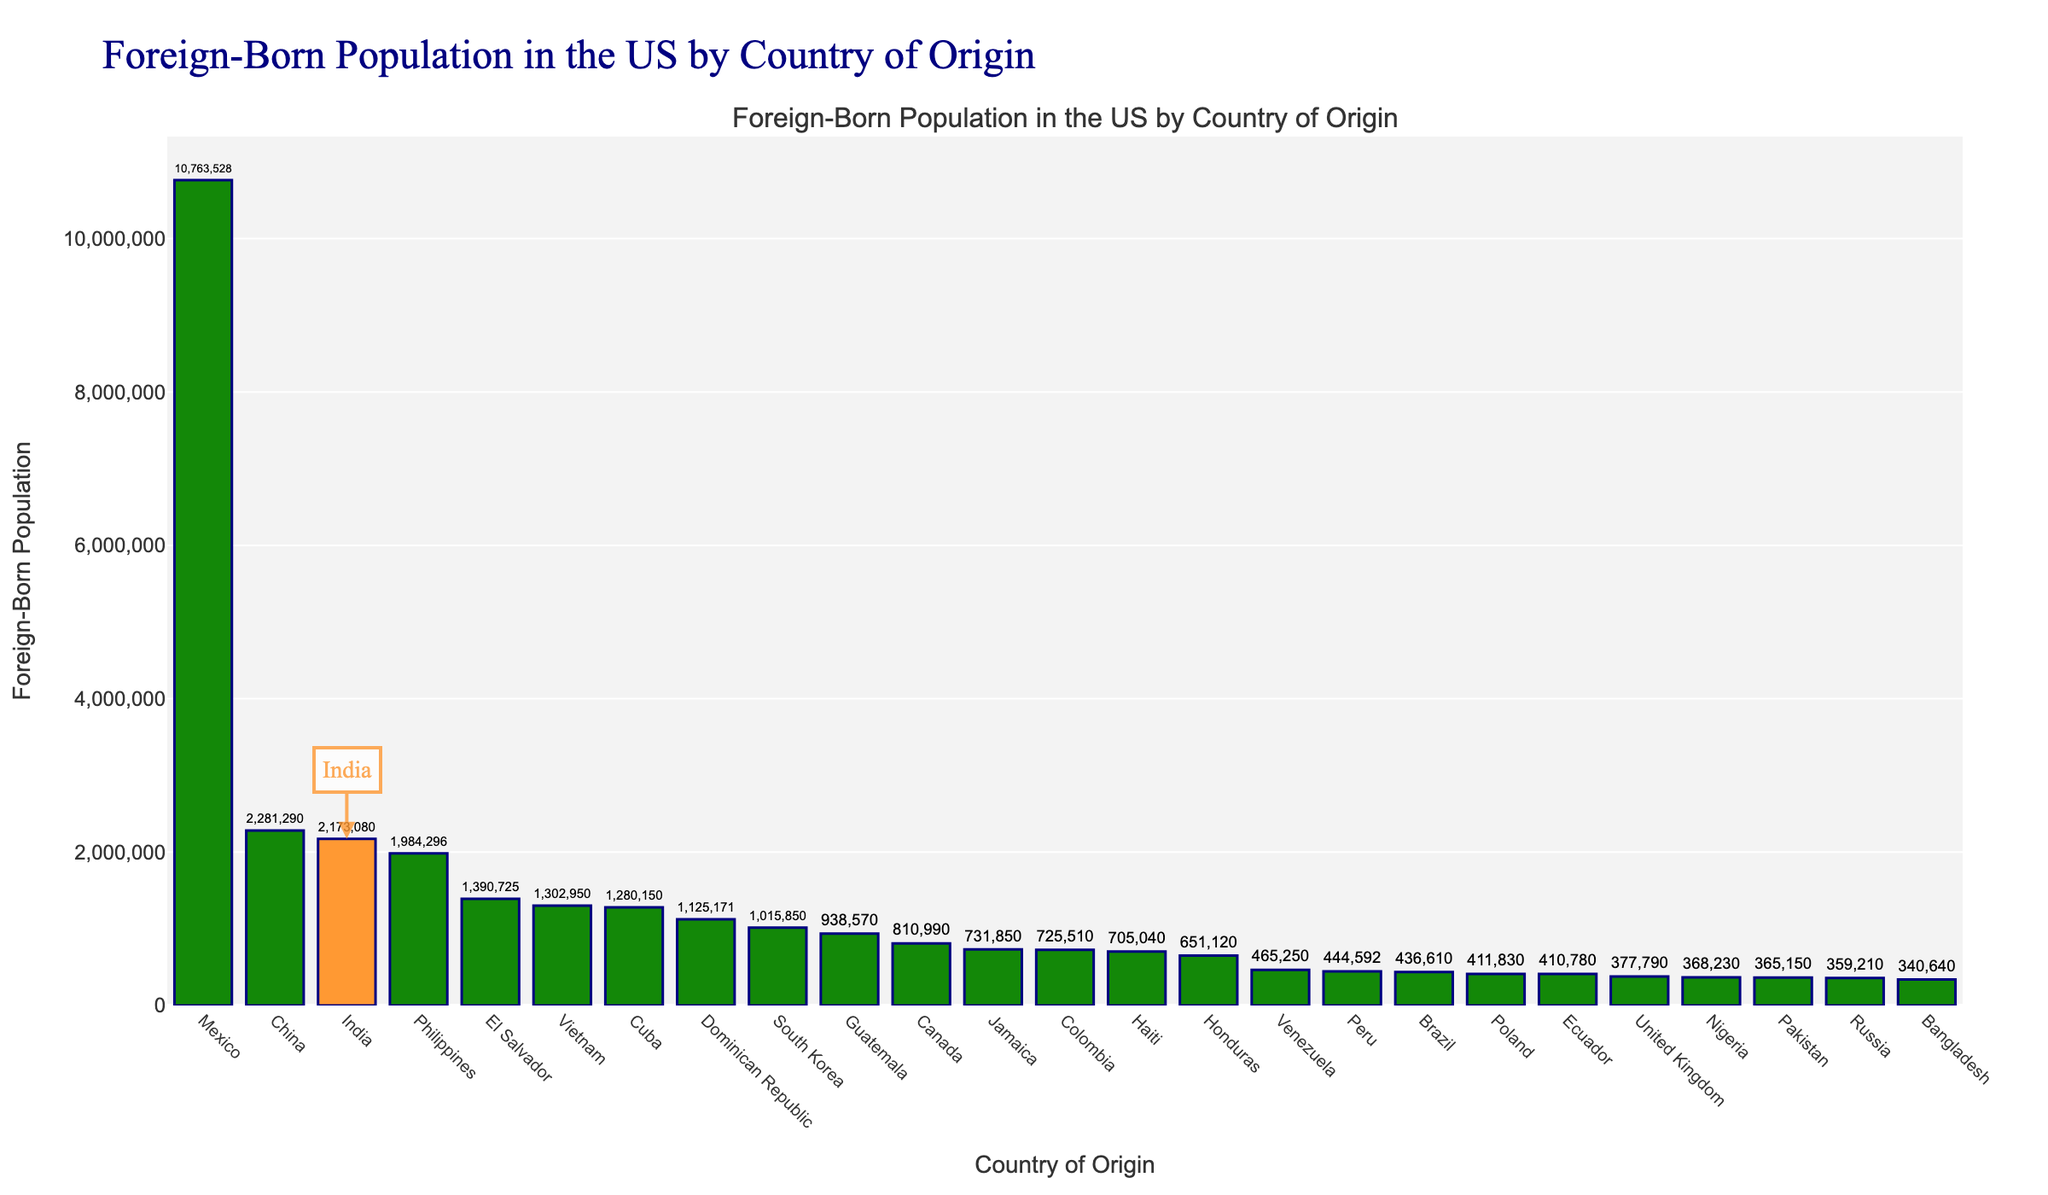Which country has the highest foreign-born population in the US? Mexico has the highest foreign-born population in the US as shown by the tallest bar in the chart.
Answer: Mexico What is the foreign-born population from India and how does it compare to China? The foreign-born population from India is 2,173,080, which is lower than China's foreign-born population of 2,281,290, as illustrated by the heights of the bars representing India and China.
Answer: 2,173,080; lower than China How many countries have a foreign-born population of over 1 million? By counting the bars that extend to over 1 million, we can see that there are 9 countries with foreign-born populations over 1 million in the US.
Answer: 9 What is the combined foreign-born population from the Philippines and Vietnam? The foreign-born population from the Philippines is 1,984,296 and from Vietnam is 1,302,950. Adding these together gives 1,984,296 + 1,302,950 = 3,287,246.
Answer: 3,287,246 Which country has the smallest foreign-born population and what is that population? Bangladesh has the smallest foreign-born population among the listed countries, with a population of 340,640, as shown by the shortest bar in the chart.
Answer: Bangladesh; 340,640 How much larger is the foreign-born population from Mexico compared to India? The foreign-born population from Mexico is 10,763,528, and from India is 2,173,080. Subtracting these gives 10,763,528 - 2,173,080 = 8,590,448.
Answer: 8,590,448 Identify the countries of origin marked with orange and green colors. India's bar is marked with orange, and all other countries' bars are marked with green in the chart based on the visual color attributes shown.
Answer: India (orange), others (green) What is the total foreign-born population from the top 3 countries? Mexico: 10,763,528, China: 2,281,290, India: 2,173,080. Summing these gives 10,763,528 + 2,281,290 + 2,173,080 = 15,217,898.
Answer: 15,217,898 How many countries have a foreign-born population less than 500,000, and name one of them? By counting the bars below the 500,000 mark, there are 6 countries, and one of them is Nigeria.
Answer: 6; Nigeria 